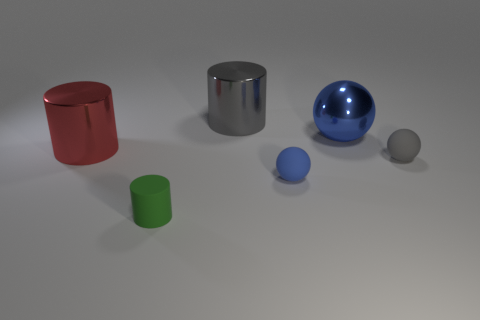What materials do these objects appear to be made of? The cylindrical and large spherical objects appear to be metallic, possibly steel or aluminum, while the other objects seem to be made of matte materials such as plastic. Can you infer the sizes of these objects in relation to each other? Certainly. The metallic cylinder and the blue metallic ball are the largest objects. The red and green objects appear to be smaller, with the green one being the smallest visible object. 